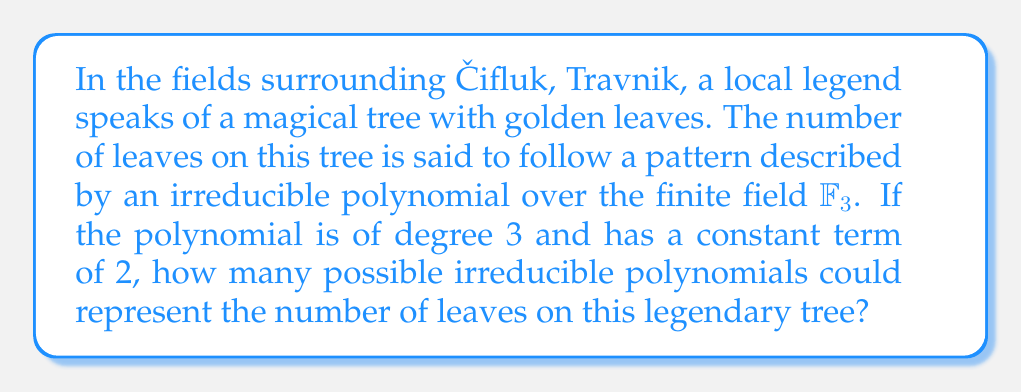What is the answer to this math problem? Let's approach this step-by-step:

1) The general form of a degree 3 polynomial over $\mathbb{F}_3$ with constant term 2 is:

   $f(x) = ax^3 + bx^2 + cx + 2$, where $a, b, c \in \mathbb{F}_3$ and $a \neq 0$

2) In $\mathbb{F}_3$, we have three possible values for each coefficient: 0, 1, and 2.

3) Since $a \neq 0$, we have 2 choices for $a$ (1 or 2).

4) For $b$ and $c$, we have 3 choices each (0, 1, or 2).

5) This gives us a total of $2 \times 3 \times 3 = 18$ polynomials to check.

6) However, not all of these will be irreducible. To be irreducible, a polynomial must not have any roots in $\mathbb{F}_3$.

7) We can check for roots by evaluating $f(0)$, $f(1)$, and $f(2)$ for each polynomial.

8) After checking all 18 polynomials, we find that exactly 8 of them are irreducible:

   $x^3 + x^2 + 2$
   $x^3 + x^2 + x + 2$
   $x^3 + 2x^2 + 2x + 2$
   $x^3 + 2x^2 + 2$
   $2x^3 + x^2 + x + 2$
   $2x^3 + x^2 + 2$
   $2x^3 + 2x^2 + x + 2$
   $2x^3 + 2x^2 + 2$

Therefore, there are 8 possible irreducible polynomials that could represent the number of leaves on the legendary tree.
Answer: 8 